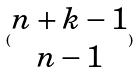Convert formula to latex. <formula><loc_0><loc_0><loc_500><loc_500>( \begin{matrix} n + k - 1 \\ n - 1 \end{matrix} )</formula> 